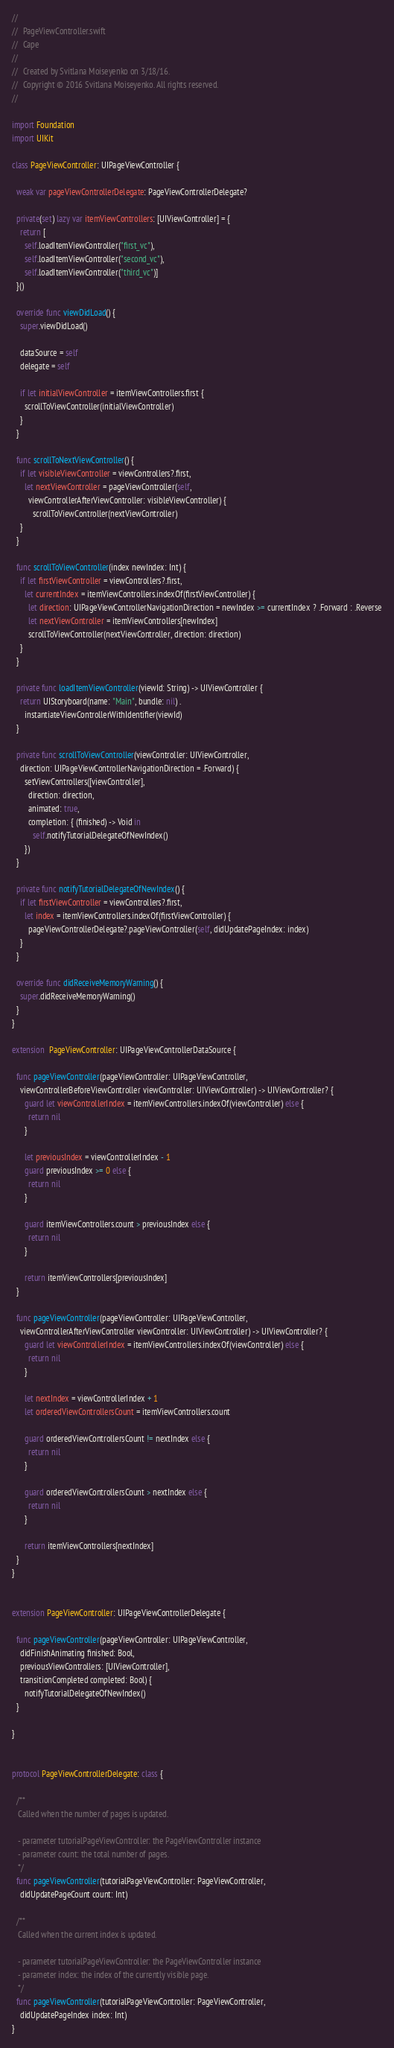Convert code to text. <code><loc_0><loc_0><loc_500><loc_500><_Swift_>//
//  PageViewController.swift
//  Cape
//
//  Created by Svitlana Moiseyenko on 3/18/16.
//  Copyright © 2016 Svitlana Moiseyenko. All rights reserved.
//

import Foundation
import UIKit

class PageViewController: UIPageViewController {
  
  weak var pageViewControllerDelegate: PageViewControllerDelegate?
  
  private(set) lazy var itemViewControllers: [UIViewController] = {
    return [
      self.loadItemViewController("first_vc"),
      self.loadItemViewController("second_vc"),
      self.loadItemViewController("third_vc")]
  }()
  
  override func viewDidLoad() {
    super.viewDidLoad()
    
    dataSource = self
    delegate = self
    
    if let initialViewController = itemViewControllers.first {
      scrollToViewController(initialViewController)
    }
  }
  
  func scrollToNextViewController() {
    if let visibleViewController = viewControllers?.first,
      let nextViewController = pageViewController(self,
        viewControllerAfterViewController: visibleViewController) {
          scrollToViewController(nextViewController)
    }
  }
  
  func scrollToViewController(index newIndex: Int) {
    if let firstViewController = viewControllers?.first,
      let currentIndex = itemViewControllers.indexOf(firstViewController) {
        let direction: UIPageViewControllerNavigationDirection = newIndex >= currentIndex ? .Forward : .Reverse
        let nextViewController = itemViewControllers[newIndex]
        scrollToViewController(nextViewController, direction: direction)
    }
  }
  
  private func loadItemViewController(viewId: String) -> UIViewController {
    return UIStoryboard(name: "Main", bundle: nil) .
      instantiateViewControllerWithIdentifier(viewId)
  }
  
  private func scrollToViewController(viewController: UIViewController,
    direction: UIPageViewControllerNavigationDirection = .Forward) {
      setViewControllers([viewController],
        direction: direction,
        animated: true,
        completion: { (finished) -> Void in
          self.notifyTutorialDelegateOfNewIndex()
      })
  }
  
  private func notifyTutorialDelegateOfNewIndex() {
    if let firstViewController = viewControllers?.first,
      let index = itemViewControllers.indexOf(firstViewController) {
        pageViewControllerDelegate?.pageViewController(self, didUpdatePageIndex: index)
    }
  }
  
  override func didReceiveMemoryWarning() {
    super.didReceiveMemoryWarning()
  }
}

extension  PageViewController: UIPageViewControllerDataSource {
  
  func pageViewController(pageViewController: UIPageViewController,
    viewControllerBeforeViewController viewController: UIViewController) -> UIViewController? {
      guard let viewControllerIndex = itemViewControllers.indexOf(viewController) else {
        return nil
      }
      
      let previousIndex = viewControllerIndex - 1
      guard previousIndex >= 0 else {
        return nil
      }
      
      guard itemViewControllers.count > previousIndex else {
        return nil
      }
      
      return itemViewControllers[previousIndex]
  }
  
  func pageViewController(pageViewController: UIPageViewController,
    viewControllerAfterViewController viewController: UIViewController) -> UIViewController? {
      guard let viewControllerIndex = itemViewControllers.indexOf(viewController) else {
        return nil
      }
      
      let nextIndex = viewControllerIndex + 1
      let orderedViewControllersCount = itemViewControllers.count
      
      guard orderedViewControllersCount != nextIndex else {
        return nil
      }
      
      guard orderedViewControllersCount > nextIndex else {
        return nil
      }
      
      return itemViewControllers[nextIndex]
  }
}


extension PageViewController: UIPageViewControllerDelegate {
  
  func pageViewController(pageViewController: UIPageViewController,
    didFinishAnimating finished: Bool,
    previousViewControllers: [UIViewController],
    transitionCompleted completed: Bool) {
      notifyTutorialDelegateOfNewIndex()
  }
  
}


protocol PageViewControllerDelegate: class {
  
  /**
   Called when the number of pages is updated.
   
   - parameter tutorialPageViewController: the PageViewController instance
   - parameter count: the total number of pages.
   */
  func pageViewController(tutorialPageViewController: PageViewController,
    didUpdatePageCount count: Int)
  
  /**
   Called when the current index is updated.
   
   - parameter tutorialPageViewController: the PageViewController instance
   - parameter index: the index of the currently visible page.
   */
  func pageViewController(tutorialPageViewController: PageViewController,
    didUpdatePageIndex index: Int)
}



</code> 